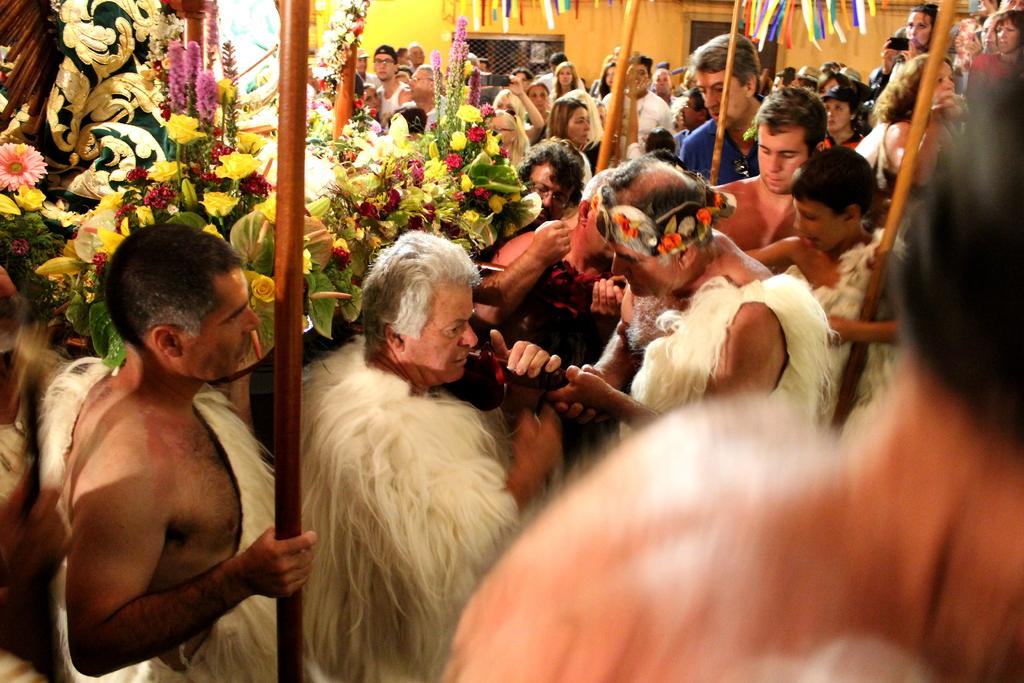What type of people can be seen in the image? There is a crowd in costumes in the image. What decorative items are present in the image? Flower bouquets and garlands are visible in the image. What objects are used in the image? Sticks are present in the image. What structures can be seen in the background of the image? There are buildings in the background of the image. What architectural features are visible in the image? There is a window and a door in the image. What can be inferred about the time of day when the image was taken? The image was likely taken during the day. What type of toe is visible in the image? There is no toe present in the image. Is there a fire visible in the image? There is no fire present in the image. What type of prison can be seen in the image? There is no prison present in the image. 